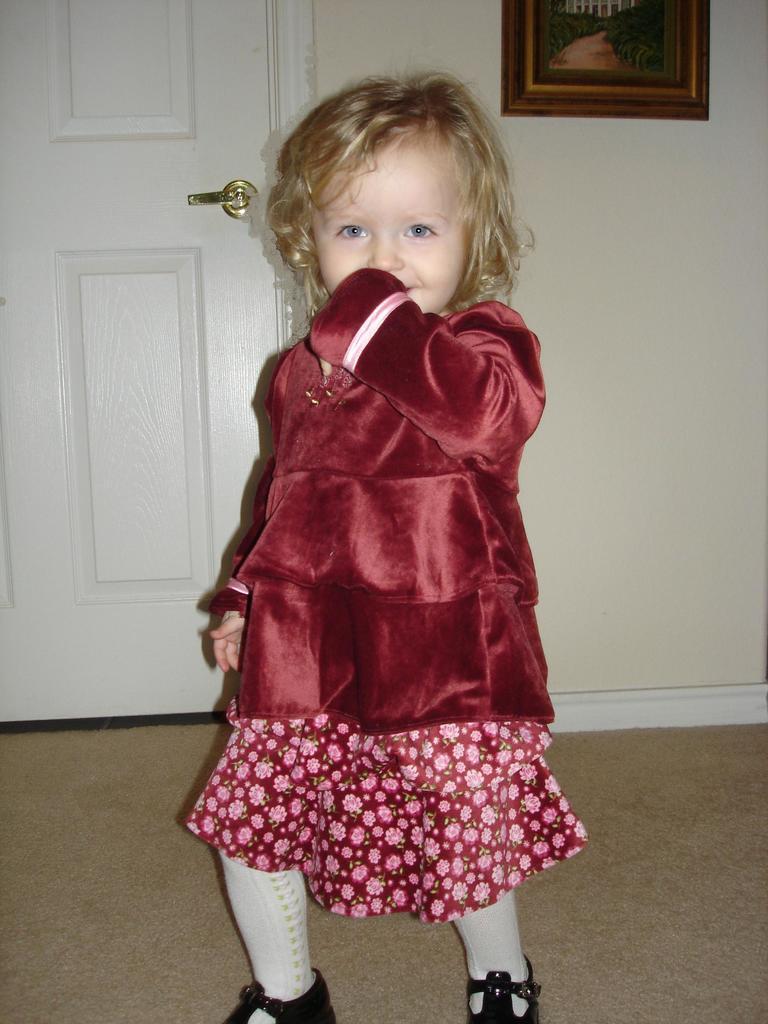In one or two sentences, can you explain what this image depicts? In the picture we can see a small girl standing inside the house and she is with red dress and frock and white socks and behind her we can see the wall with a part of the white color door and beside it we can see a wall with a part of the photo frame. 